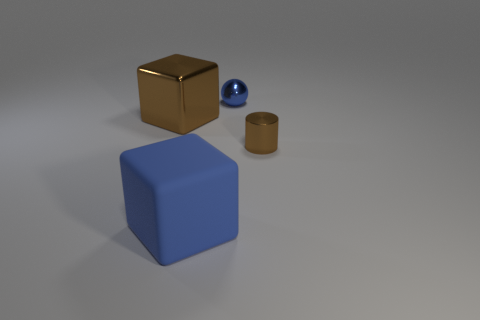Add 3 small shiny things. How many objects exist? 7 Subtract all spheres. How many objects are left? 3 Subtract all small brown metallic things. Subtract all brown metal cubes. How many objects are left? 2 Add 4 brown shiny cylinders. How many brown shiny cylinders are left? 5 Add 3 big brown cubes. How many big brown cubes exist? 4 Subtract 0 purple cylinders. How many objects are left? 4 